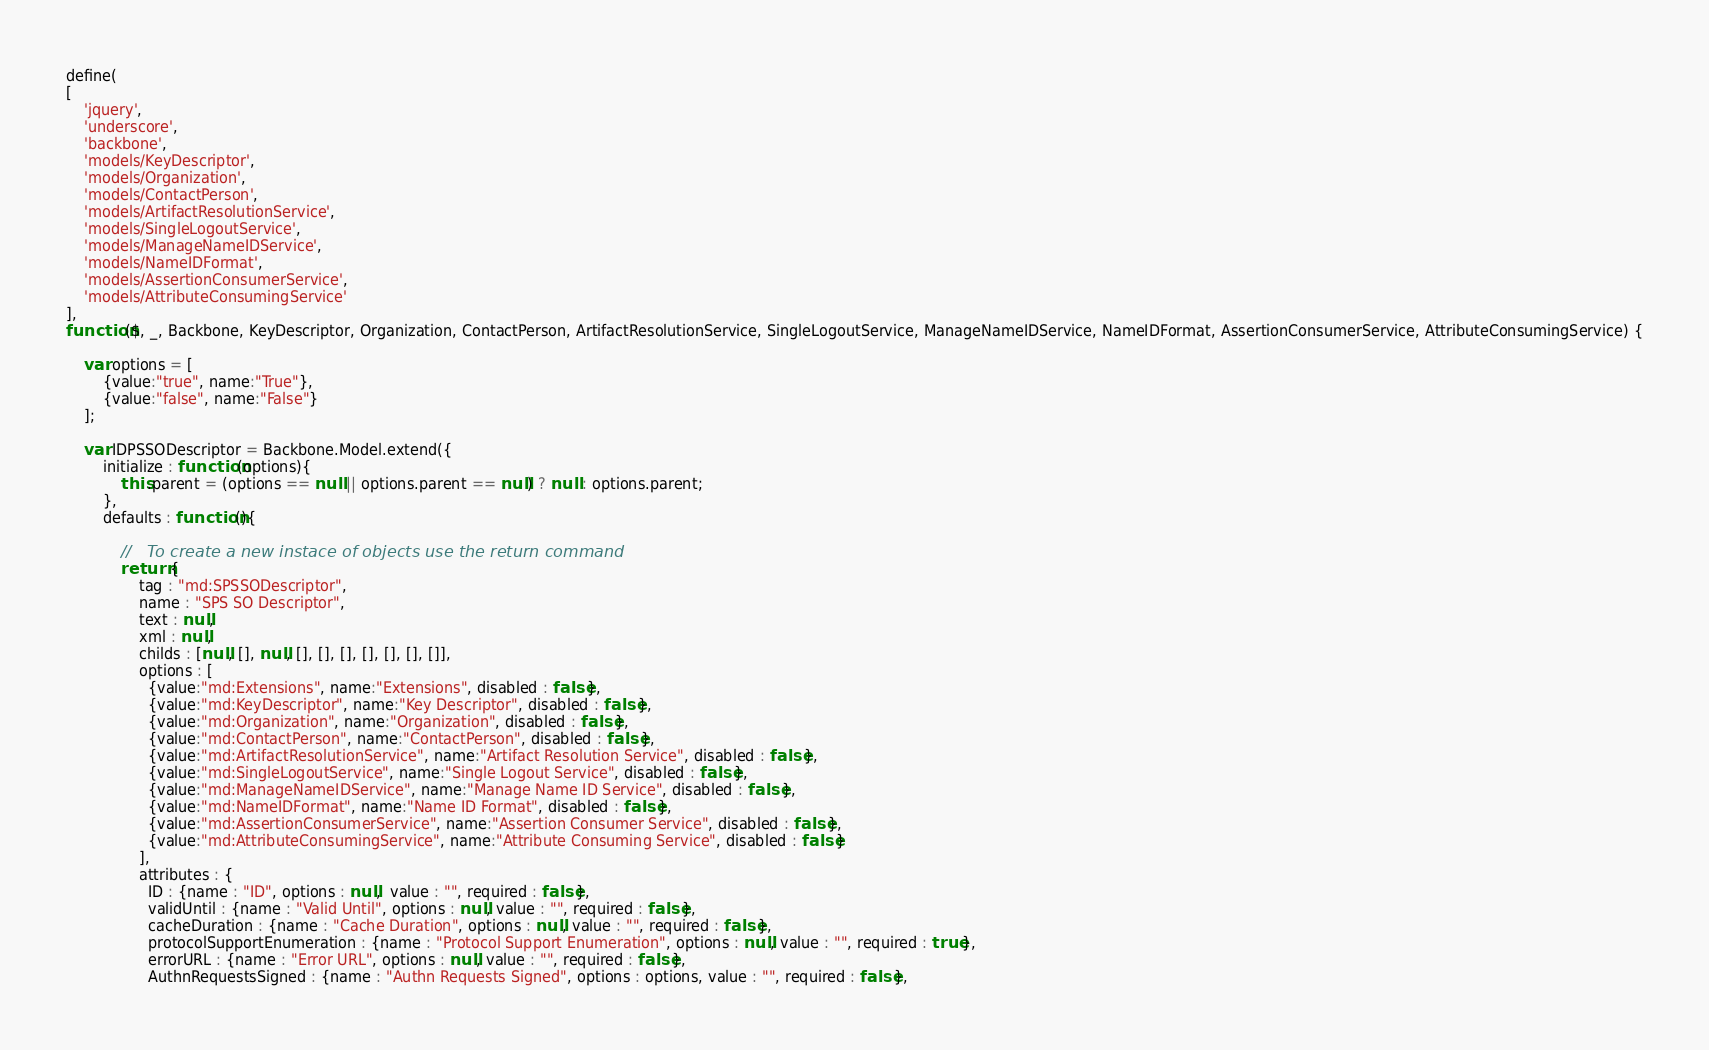<code> <loc_0><loc_0><loc_500><loc_500><_JavaScript_>define(
[ 
	'jquery', 
	'underscore', 
	'backbone',
	'models/KeyDescriptor',
	'models/Organization',
	'models/ContactPerson',
	'models/ArtifactResolutionService',
	'models/SingleLogoutService',
	'models/ManageNameIDService',
	'models/NameIDFormat',
	'models/AssertionConsumerService',
	'models/AttributeConsumingService'
], 
function($, _, Backbone, KeyDescriptor, Organization, ContactPerson, ArtifactResolutionService, SingleLogoutService, ManageNameIDService, NameIDFormat, AssertionConsumerService, AttributeConsumingService) {

	var options = [
    	{value:"true", name:"True"},
    	{value:"false", name:"False"}
	];
	
	var IDPSSODescriptor = Backbone.Model.extend({
		initialize : function(options){
	        this.parent = (options == null || options.parent == null) ? null : options.parent;
		},
		defaults : function(){
			
			//	 To create a new instace of objects use the return command
			return {
				tag : "md:SPSSODescriptor",
				name : "SPS SO Descriptor",
				text : null,
				xml : null,
				childs : [null, [], null, [], [], [], [], [], [], []],
				options : [
		          {value:"md:Extensions", name:"Extensions", disabled : false},
		          {value:"md:KeyDescriptor", name:"Key Descriptor", disabled : false},
		          {value:"md:Organization", name:"Organization", disabled : false},
		          {value:"md:ContactPerson", name:"ContactPerson", disabled : false},
		          {value:"md:ArtifactResolutionService", name:"Artifact Resolution Service", disabled : false},
		          {value:"md:SingleLogoutService", name:"Single Logout Service", disabled : false},
		          {value:"md:ManageNameIDService", name:"Manage Name ID Service", disabled : false},
		          {value:"md:NameIDFormat", name:"Name ID Format", disabled : false},
		          {value:"md:AssertionConsumerService", name:"Assertion Consumer Service", disabled : false},
		          {value:"md:AttributeConsumingService", name:"Attribute Consuming Service", disabled : false}
				],
				attributes : {
				  ID : {name : "ID", options : null,  value : "", required : false},
		          validUntil : {name : "Valid Until", options : null, value : "", required : false},
		          cacheDuration : {name : "Cache Duration", options : null, value : "", required : false},
		          protocolSupportEnumeration : {name : "Protocol Support Enumeration", options : null, value : "", required : true},
		          errorURL : {name : "Error URL", options : null, value : "", required : false},
		          AuthnRequestsSigned : {name : "Authn Requests Signed", options : options, value : "", required : false},</code> 